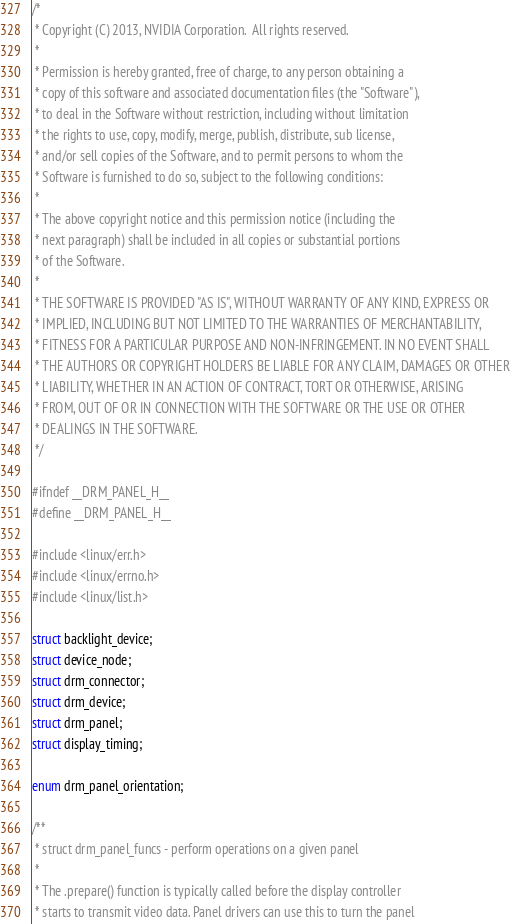<code> <loc_0><loc_0><loc_500><loc_500><_C_>/*
 * Copyright (C) 2013, NVIDIA Corporation.  All rights reserved.
 *
 * Permission is hereby granted, free of charge, to any person obtaining a
 * copy of this software and associated documentation files (the "Software"),
 * to deal in the Software without restriction, including without limitation
 * the rights to use, copy, modify, merge, publish, distribute, sub license,
 * and/or sell copies of the Software, and to permit persons to whom the
 * Software is furnished to do so, subject to the following conditions:
 *
 * The above copyright notice and this permission notice (including the
 * next paragraph) shall be included in all copies or substantial portions
 * of the Software.
 *
 * THE SOFTWARE IS PROVIDED "AS IS", WITHOUT WARRANTY OF ANY KIND, EXPRESS OR
 * IMPLIED, INCLUDING BUT NOT LIMITED TO THE WARRANTIES OF MERCHANTABILITY,
 * FITNESS FOR A PARTICULAR PURPOSE AND NON-INFRINGEMENT. IN NO EVENT SHALL
 * THE AUTHORS OR COPYRIGHT HOLDERS BE LIABLE FOR ANY CLAIM, DAMAGES OR OTHER
 * LIABILITY, WHETHER IN AN ACTION OF CONTRACT, TORT OR OTHERWISE, ARISING
 * FROM, OUT OF OR IN CONNECTION WITH THE SOFTWARE OR THE USE OR OTHER
 * DEALINGS IN THE SOFTWARE.
 */

#ifndef __DRM_PANEL_H__
#define __DRM_PANEL_H__

#include <linux/err.h>
#include <linux/errno.h>
#include <linux/list.h>

struct backlight_device;
struct device_node;
struct drm_connector;
struct drm_device;
struct drm_panel;
struct display_timing;

enum drm_panel_orientation;

/**
 * struct drm_panel_funcs - perform operations on a given panel
 *
 * The .prepare() function is typically called before the display controller
 * starts to transmit video data. Panel drivers can use this to turn the panel</code> 